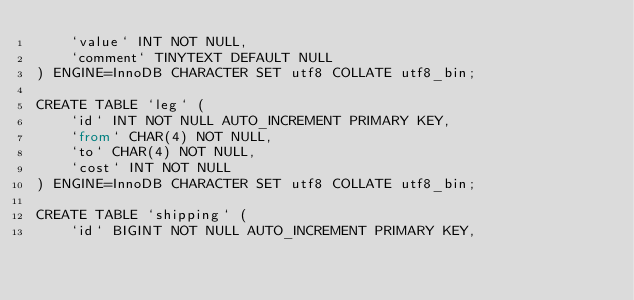<code> <loc_0><loc_0><loc_500><loc_500><_SQL_>    `value` INT NOT NULL,
    `comment` TINYTEXT DEFAULT NULL
) ENGINE=InnoDB CHARACTER SET utf8 COLLATE utf8_bin;

CREATE TABLE `leg` (
    `id` INT NOT NULL AUTO_INCREMENT PRIMARY KEY,
    `from` CHAR(4) NOT NULL,
    `to` CHAR(4) NOT NULL,
    `cost` INT NOT NULL
) ENGINE=InnoDB CHARACTER SET utf8 COLLATE utf8_bin;

CREATE TABLE `shipping` (
    `id` BIGINT NOT NULL AUTO_INCREMENT PRIMARY KEY,</code> 